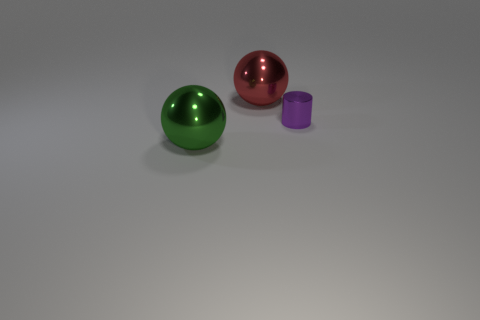Add 1 gray matte blocks. How many objects exist? 4 Subtract all cylinders. How many objects are left? 2 Add 2 green balls. How many green balls are left? 3 Add 3 large balls. How many large balls exist? 5 Subtract 0 red blocks. How many objects are left? 3 Subtract all big balls. Subtract all green shiny things. How many objects are left? 0 